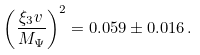Convert formula to latex. <formula><loc_0><loc_0><loc_500><loc_500>\left ( \frac { \xi _ { 3 } v } { M _ { \Psi } } \right ) ^ { 2 } = 0 . 0 5 9 \pm 0 . 0 1 6 \, .</formula> 